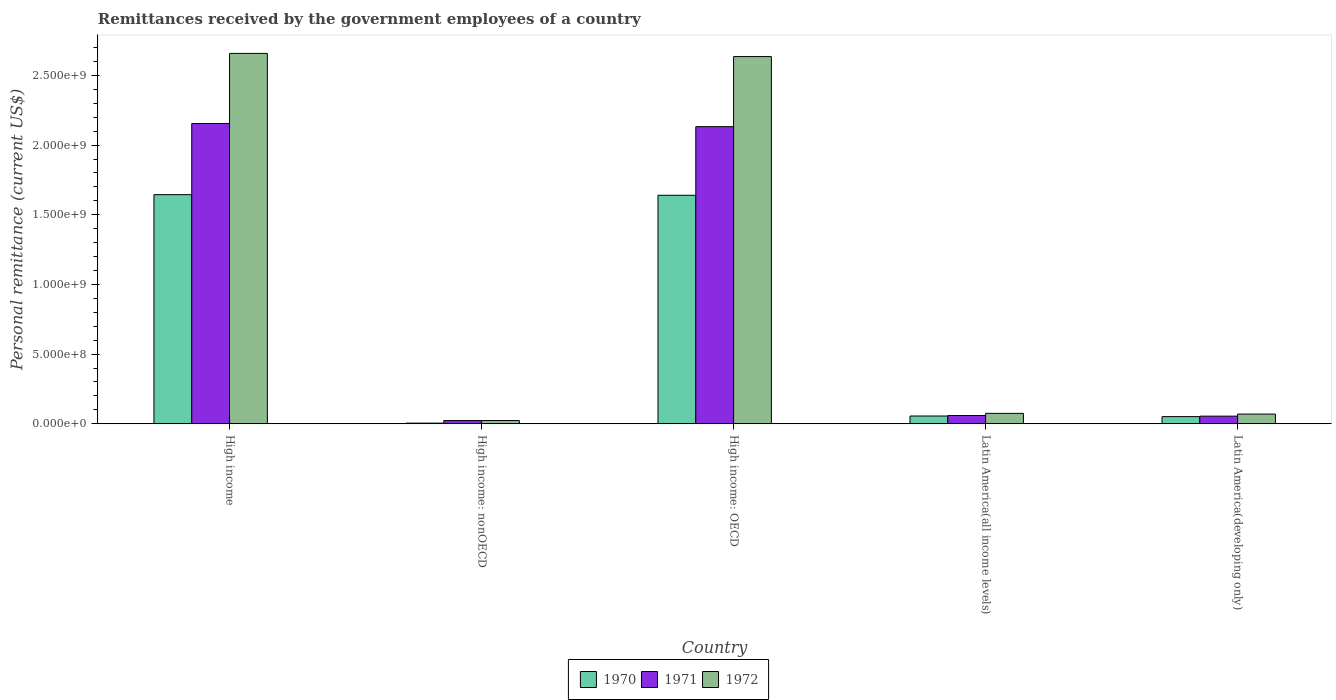Are the number of bars per tick equal to the number of legend labels?
Keep it short and to the point. Yes. Are the number of bars on each tick of the X-axis equal?
Your answer should be compact. Yes. How many bars are there on the 5th tick from the left?
Your answer should be very brief. 3. How many bars are there on the 4th tick from the right?
Ensure brevity in your answer.  3. What is the remittances received by the government employees in 1972 in Latin America(all income levels)?
Give a very brief answer. 7.45e+07. Across all countries, what is the maximum remittances received by the government employees in 1970?
Keep it short and to the point. 1.64e+09. Across all countries, what is the minimum remittances received by the government employees in 1972?
Your response must be concise. 2.29e+07. In which country was the remittances received by the government employees in 1972 minimum?
Offer a terse response. High income: nonOECD. What is the total remittances received by the government employees in 1970 in the graph?
Keep it short and to the point. 3.40e+09. What is the difference between the remittances received by the government employees in 1970 in High income: nonOECD and that in Latin America(developing only)?
Your response must be concise. -4.67e+07. What is the difference between the remittances received by the government employees in 1972 in Latin America(all income levels) and the remittances received by the government employees in 1971 in Latin America(developing only)?
Your answer should be compact. 2.00e+07. What is the average remittances received by the government employees in 1970 per country?
Offer a very short reply. 6.79e+08. What is the difference between the remittances received by the government employees of/in 1972 and remittances received by the government employees of/in 1971 in Latin America(developing only)?
Offer a very short reply. 1.49e+07. What is the ratio of the remittances received by the government employees in 1972 in High income: nonOECD to that in Latin America(all income levels)?
Make the answer very short. 0.31. Is the remittances received by the government employees in 1972 in High income less than that in High income: nonOECD?
Your answer should be compact. No. What is the difference between the highest and the second highest remittances received by the government employees in 1970?
Keep it short and to the point. -1.59e+09. What is the difference between the highest and the lowest remittances received by the government employees in 1970?
Offer a terse response. 1.64e+09. What does the 3rd bar from the left in High income: OECD represents?
Provide a succinct answer. 1972. Is it the case that in every country, the sum of the remittances received by the government employees in 1971 and remittances received by the government employees in 1972 is greater than the remittances received by the government employees in 1970?
Your response must be concise. Yes. How many bars are there?
Keep it short and to the point. 15. How many countries are there in the graph?
Keep it short and to the point. 5. What is the difference between two consecutive major ticks on the Y-axis?
Provide a succinct answer. 5.00e+08. Are the values on the major ticks of Y-axis written in scientific E-notation?
Keep it short and to the point. Yes. Does the graph contain grids?
Your response must be concise. No. How many legend labels are there?
Offer a terse response. 3. How are the legend labels stacked?
Your answer should be very brief. Horizontal. What is the title of the graph?
Provide a succinct answer. Remittances received by the government employees of a country. What is the label or title of the Y-axis?
Offer a very short reply. Personal remittance (current US$). What is the Personal remittance (current US$) in 1970 in High income?
Offer a very short reply. 1.64e+09. What is the Personal remittance (current US$) in 1971 in High income?
Provide a succinct answer. 2.16e+09. What is the Personal remittance (current US$) of 1972 in High income?
Provide a short and direct response. 2.66e+09. What is the Personal remittance (current US$) of 1970 in High income: nonOECD?
Provide a succinct answer. 4.40e+06. What is the Personal remittance (current US$) of 1971 in High income: nonOECD?
Give a very brief answer. 2.28e+07. What is the Personal remittance (current US$) in 1972 in High income: nonOECD?
Your answer should be very brief. 2.29e+07. What is the Personal remittance (current US$) in 1970 in High income: OECD?
Offer a very short reply. 1.64e+09. What is the Personal remittance (current US$) in 1971 in High income: OECD?
Offer a terse response. 2.13e+09. What is the Personal remittance (current US$) of 1972 in High income: OECD?
Ensure brevity in your answer.  2.64e+09. What is the Personal remittance (current US$) in 1970 in Latin America(all income levels)?
Provide a succinct answer. 5.55e+07. What is the Personal remittance (current US$) in 1971 in Latin America(all income levels)?
Provide a succinct answer. 5.91e+07. What is the Personal remittance (current US$) of 1972 in Latin America(all income levels)?
Your response must be concise. 7.45e+07. What is the Personal remittance (current US$) of 1970 in Latin America(developing only)?
Ensure brevity in your answer.  5.11e+07. What is the Personal remittance (current US$) in 1971 in Latin America(developing only)?
Offer a very short reply. 5.45e+07. What is the Personal remittance (current US$) of 1972 in Latin America(developing only)?
Your response must be concise. 6.94e+07. Across all countries, what is the maximum Personal remittance (current US$) of 1970?
Give a very brief answer. 1.64e+09. Across all countries, what is the maximum Personal remittance (current US$) of 1971?
Your answer should be very brief. 2.16e+09. Across all countries, what is the maximum Personal remittance (current US$) of 1972?
Give a very brief answer. 2.66e+09. Across all countries, what is the minimum Personal remittance (current US$) in 1970?
Offer a very short reply. 4.40e+06. Across all countries, what is the minimum Personal remittance (current US$) of 1971?
Your answer should be very brief. 2.28e+07. Across all countries, what is the minimum Personal remittance (current US$) in 1972?
Offer a very short reply. 2.29e+07. What is the total Personal remittance (current US$) in 1970 in the graph?
Your answer should be compact. 3.40e+09. What is the total Personal remittance (current US$) in 1971 in the graph?
Your answer should be very brief. 4.42e+09. What is the total Personal remittance (current US$) of 1972 in the graph?
Ensure brevity in your answer.  5.46e+09. What is the difference between the Personal remittance (current US$) in 1970 in High income and that in High income: nonOECD?
Provide a succinct answer. 1.64e+09. What is the difference between the Personal remittance (current US$) in 1971 in High income and that in High income: nonOECD?
Provide a short and direct response. 2.13e+09. What is the difference between the Personal remittance (current US$) in 1972 in High income and that in High income: nonOECD?
Your answer should be compact. 2.64e+09. What is the difference between the Personal remittance (current US$) in 1970 in High income and that in High income: OECD?
Ensure brevity in your answer.  4.40e+06. What is the difference between the Personal remittance (current US$) of 1971 in High income and that in High income: OECD?
Make the answer very short. 2.28e+07. What is the difference between the Personal remittance (current US$) of 1972 in High income and that in High income: OECD?
Give a very brief answer. 2.29e+07. What is the difference between the Personal remittance (current US$) in 1970 in High income and that in Latin America(all income levels)?
Offer a very short reply. 1.59e+09. What is the difference between the Personal remittance (current US$) in 1971 in High income and that in Latin America(all income levels)?
Your answer should be very brief. 2.10e+09. What is the difference between the Personal remittance (current US$) of 1972 in High income and that in Latin America(all income levels)?
Your answer should be very brief. 2.58e+09. What is the difference between the Personal remittance (current US$) of 1970 in High income and that in Latin America(developing only)?
Provide a short and direct response. 1.59e+09. What is the difference between the Personal remittance (current US$) of 1971 in High income and that in Latin America(developing only)?
Your answer should be very brief. 2.10e+09. What is the difference between the Personal remittance (current US$) in 1972 in High income and that in Latin America(developing only)?
Your answer should be compact. 2.59e+09. What is the difference between the Personal remittance (current US$) in 1970 in High income: nonOECD and that in High income: OECD?
Offer a terse response. -1.64e+09. What is the difference between the Personal remittance (current US$) in 1971 in High income: nonOECD and that in High income: OECD?
Provide a succinct answer. -2.11e+09. What is the difference between the Personal remittance (current US$) in 1972 in High income: nonOECD and that in High income: OECD?
Provide a short and direct response. -2.61e+09. What is the difference between the Personal remittance (current US$) of 1970 in High income: nonOECD and that in Latin America(all income levels)?
Offer a terse response. -5.11e+07. What is the difference between the Personal remittance (current US$) in 1971 in High income: nonOECD and that in Latin America(all income levels)?
Make the answer very short. -3.63e+07. What is the difference between the Personal remittance (current US$) of 1972 in High income: nonOECD and that in Latin America(all income levels)?
Offer a terse response. -5.16e+07. What is the difference between the Personal remittance (current US$) of 1970 in High income: nonOECD and that in Latin America(developing only)?
Provide a succinct answer. -4.67e+07. What is the difference between the Personal remittance (current US$) in 1971 in High income: nonOECD and that in Latin America(developing only)?
Make the answer very short. -3.17e+07. What is the difference between the Personal remittance (current US$) of 1972 in High income: nonOECD and that in Latin America(developing only)?
Your response must be concise. -4.65e+07. What is the difference between the Personal remittance (current US$) in 1970 in High income: OECD and that in Latin America(all income levels)?
Make the answer very short. 1.58e+09. What is the difference between the Personal remittance (current US$) in 1971 in High income: OECD and that in Latin America(all income levels)?
Make the answer very short. 2.07e+09. What is the difference between the Personal remittance (current US$) of 1972 in High income: OECD and that in Latin America(all income levels)?
Provide a succinct answer. 2.56e+09. What is the difference between the Personal remittance (current US$) in 1970 in High income: OECD and that in Latin America(developing only)?
Offer a terse response. 1.59e+09. What is the difference between the Personal remittance (current US$) in 1971 in High income: OECD and that in Latin America(developing only)?
Offer a very short reply. 2.08e+09. What is the difference between the Personal remittance (current US$) in 1972 in High income: OECD and that in Latin America(developing only)?
Give a very brief answer. 2.57e+09. What is the difference between the Personal remittance (current US$) of 1970 in Latin America(all income levels) and that in Latin America(developing only)?
Provide a succinct answer. 4.40e+06. What is the difference between the Personal remittance (current US$) of 1971 in Latin America(all income levels) and that in Latin America(developing only)?
Your answer should be compact. 4.61e+06. What is the difference between the Personal remittance (current US$) in 1972 in Latin America(all income levels) and that in Latin America(developing only)?
Your answer should be very brief. 5.10e+06. What is the difference between the Personal remittance (current US$) in 1970 in High income and the Personal remittance (current US$) in 1971 in High income: nonOECD?
Provide a short and direct response. 1.62e+09. What is the difference between the Personal remittance (current US$) of 1970 in High income and the Personal remittance (current US$) of 1972 in High income: nonOECD?
Make the answer very short. 1.62e+09. What is the difference between the Personal remittance (current US$) of 1971 in High income and the Personal remittance (current US$) of 1972 in High income: nonOECD?
Your answer should be very brief. 2.13e+09. What is the difference between the Personal remittance (current US$) in 1970 in High income and the Personal remittance (current US$) in 1971 in High income: OECD?
Provide a short and direct response. -4.88e+08. What is the difference between the Personal remittance (current US$) of 1970 in High income and the Personal remittance (current US$) of 1972 in High income: OECD?
Give a very brief answer. -9.91e+08. What is the difference between the Personal remittance (current US$) of 1971 in High income and the Personal remittance (current US$) of 1972 in High income: OECD?
Your response must be concise. -4.80e+08. What is the difference between the Personal remittance (current US$) of 1970 in High income and the Personal remittance (current US$) of 1971 in Latin America(all income levels)?
Give a very brief answer. 1.59e+09. What is the difference between the Personal remittance (current US$) of 1970 in High income and the Personal remittance (current US$) of 1972 in Latin America(all income levels)?
Keep it short and to the point. 1.57e+09. What is the difference between the Personal remittance (current US$) in 1971 in High income and the Personal remittance (current US$) in 1972 in Latin America(all income levels)?
Your answer should be compact. 2.08e+09. What is the difference between the Personal remittance (current US$) in 1970 in High income and the Personal remittance (current US$) in 1971 in Latin America(developing only)?
Ensure brevity in your answer.  1.59e+09. What is the difference between the Personal remittance (current US$) of 1970 in High income and the Personal remittance (current US$) of 1972 in Latin America(developing only)?
Ensure brevity in your answer.  1.58e+09. What is the difference between the Personal remittance (current US$) in 1971 in High income and the Personal remittance (current US$) in 1972 in Latin America(developing only)?
Your response must be concise. 2.09e+09. What is the difference between the Personal remittance (current US$) in 1970 in High income: nonOECD and the Personal remittance (current US$) in 1971 in High income: OECD?
Ensure brevity in your answer.  -2.13e+09. What is the difference between the Personal remittance (current US$) in 1970 in High income: nonOECD and the Personal remittance (current US$) in 1972 in High income: OECD?
Offer a terse response. -2.63e+09. What is the difference between the Personal remittance (current US$) in 1971 in High income: nonOECD and the Personal remittance (current US$) in 1972 in High income: OECD?
Your answer should be compact. -2.61e+09. What is the difference between the Personal remittance (current US$) of 1970 in High income: nonOECD and the Personal remittance (current US$) of 1971 in Latin America(all income levels)?
Keep it short and to the point. -5.47e+07. What is the difference between the Personal remittance (current US$) in 1970 in High income: nonOECD and the Personal remittance (current US$) in 1972 in Latin America(all income levels)?
Offer a very short reply. -7.01e+07. What is the difference between the Personal remittance (current US$) of 1971 in High income: nonOECD and the Personal remittance (current US$) of 1972 in Latin America(all income levels)?
Make the answer very short. -5.17e+07. What is the difference between the Personal remittance (current US$) in 1970 in High income: nonOECD and the Personal remittance (current US$) in 1971 in Latin America(developing only)?
Offer a terse response. -5.01e+07. What is the difference between the Personal remittance (current US$) of 1970 in High income: nonOECD and the Personal remittance (current US$) of 1972 in Latin America(developing only)?
Your response must be concise. -6.50e+07. What is the difference between the Personal remittance (current US$) of 1971 in High income: nonOECD and the Personal remittance (current US$) of 1972 in Latin America(developing only)?
Provide a succinct answer. -4.66e+07. What is the difference between the Personal remittance (current US$) in 1970 in High income: OECD and the Personal remittance (current US$) in 1971 in Latin America(all income levels)?
Make the answer very short. 1.58e+09. What is the difference between the Personal remittance (current US$) in 1970 in High income: OECD and the Personal remittance (current US$) in 1972 in Latin America(all income levels)?
Offer a very short reply. 1.57e+09. What is the difference between the Personal remittance (current US$) of 1971 in High income: OECD and the Personal remittance (current US$) of 1972 in Latin America(all income levels)?
Offer a very short reply. 2.06e+09. What is the difference between the Personal remittance (current US$) of 1970 in High income: OECD and the Personal remittance (current US$) of 1971 in Latin America(developing only)?
Make the answer very short. 1.59e+09. What is the difference between the Personal remittance (current US$) of 1970 in High income: OECD and the Personal remittance (current US$) of 1972 in Latin America(developing only)?
Your response must be concise. 1.57e+09. What is the difference between the Personal remittance (current US$) in 1971 in High income: OECD and the Personal remittance (current US$) in 1972 in Latin America(developing only)?
Offer a very short reply. 2.06e+09. What is the difference between the Personal remittance (current US$) of 1970 in Latin America(all income levels) and the Personal remittance (current US$) of 1971 in Latin America(developing only)?
Provide a succinct answer. 1.03e+06. What is the difference between the Personal remittance (current US$) of 1970 in Latin America(all income levels) and the Personal remittance (current US$) of 1972 in Latin America(developing only)?
Provide a short and direct response. -1.39e+07. What is the difference between the Personal remittance (current US$) in 1971 in Latin America(all income levels) and the Personal remittance (current US$) in 1972 in Latin America(developing only)?
Provide a short and direct response. -1.03e+07. What is the average Personal remittance (current US$) in 1970 per country?
Your answer should be very brief. 6.79e+08. What is the average Personal remittance (current US$) of 1971 per country?
Ensure brevity in your answer.  8.85e+08. What is the average Personal remittance (current US$) in 1972 per country?
Provide a succinct answer. 1.09e+09. What is the difference between the Personal remittance (current US$) of 1970 and Personal remittance (current US$) of 1971 in High income?
Ensure brevity in your answer.  -5.11e+08. What is the difference between the Personal remittance (current US$) in 1970 and Personal remittance (current US$) in 1972 in High income?
Your answer should be very brief. -1.01e+09. What is the difference between the Personal remittance (current US$) in 1971 and Personal remittance (current US$) in 1972 in High income?
Provide a succinct answer. -5.03e+08. What is the difference between the Personal remittance (current US$) of 1970 and Personal remittance (current US$) of 1971 in High income: nonOECD?
Provide a short and direct response. -1.84e+07. What is the difference between the Personal remittance (current US$) in 1970 and Personal remittance (current US$) in 1972 in High income: nonOECD?
Keep it short and to the point. -1.85e+07. What is the difference between the Personal remittance (current US$) of 1971 and Personal remittance (current US$) of 1972 in High income: nonOECD?
Give a very brief answer. -1.37e+05. What is the difference between the Personal remittance (current US$) in 1970 and Personal remittance (current US$) in 1971 in High income: OECD?
Make the answer very short. -4.92e+08. What is the difference between the Personal remittance (current US$) in 1970 and Personal remittance (current US$) in 1972 in High income: OECD?
Offer a very short reply. -9.96e+08. What is the difference between the Personal remittance (current US$) in 1971 and Personal remittance (current US$) in 1972 in High income: OECD?
Provide a short and direct response. -5.03e+08. What is the difference between the Personal remittance (current US$) of 1970 and Personal remittance (current US$) of 1971 in Latin America(all income levels)?
Keep it short and to the point. -3.57e+06. What is the difference between the Personal remittance (current US$) in 1970 and Personal remittance (current US$) in 1972 in Latin America(all income levels)?
Your answer should be very brief. -1.90e+07. What is the difference between the Personal remittance (current US$) of 1971 and Personal remittance (current US$) of 1972 in Latin America(all income levels)?
Your answer should be compact. -1.54e+07. What is the difference between the Personal remittance (current US$) in 1970 and Personal remittance (current US$) in 1971 in Latin America(developing only)?
Provide a short and direct response. -3.37e+06. What is the difference between the Personal remittance (current US$) in 1970 and Personal remittance (current US$) in 1972 in Latin America(developing only)?
Your answer should be very brief. -1.83e+07. What is the difference between the Personal remittance (current US$) of 1971 and Personal remittance (current US$) of 1972 in Latin America(developing only)?
Make the answer very short. -1.49e+07. What is the ratio of the Personal remittance (current US$) in 1970 in High income to that in High income: nonOECD?
Keep it short and to the point. 373.75. What is the ratio of the Personal remittance (current US$) in 1971 in High income to that in High income: nonOECD?
Give a very brief answer. 94.6. What is the ratio of the Personal remittance (current US$) in 1972 in High income to that in High income: nonOECD?
Offer a terse response. 115.99. What is the ratio of the Personal remittance (current US$) of 1970 in High income to that in High income: OECD?
Ensure brevity in your answer.  1. What is the ratio of the Personal remittance (current US$) in 1971 in High income to that in High income: OECD?
Offer a very short reply. 1.01. What is the ratio of the Personal remittance (current US$) of 1972 in High income to that in High income: OECD?
Provide a succinct answer. 1.01. What is the ratio of the Personal remittance (current US$) in 1970 in High income to that in Latin America(all income levels)?
Provide a succinct answer. 29.63. What is the ratio of the Personal remittance (current US$) in 1971 in High income to that in Latin America(all income levels)?
Offer a very short reply. 36.49. What is the ratio of the Personal remittance (current US$) of 1972 in High income to that in Latin America(all income levels)?
Keep it short and to the point. 35.7. What is the ratio of the Personal remittance (current US$) of 1970 in High income to that in Latin America(developing only)?
Your response must be concise. 32.18. What is the ratio of the Personal remittance (current US$) of 1971 in High income to that in Latin America(developing only)?
Provide a short and direct response. 39.57. What is the ratio of the Personal remittance (current US$) in 1972 in High income to that in Latin America(developing only)?
Keep it short and to the point. 38.32. What is the ratio of the Personal remittance (current US$) in 1970 in High income: nonOECD to that in High income: OECD?
Provide a short and direct response. 0. What is the ratio of the Personal remittance (current US$) of 1971 in High income: nonOECD to that in High income: OECD?
Make the answer very short. 0.01. What is the ratio of the Personal remittance (current US$) in 1972 in High income: nonOECD to that in High income: OECD?
Offer a terse response. 0.01. What is the ratio of the Personal remittance (current US$) in 1970 in High income: nonOECD to that in Latin America(all income levels)?
Make the answer very short. 0.08. What is the ratio of the Personal remittance (current US$) of 1971 in High income: nonOECD to that in Latin America(all income levels)?
Keep it short and to the point. 0.39. What is the ratio of the Personal remittance (current US$) of 1972 in High income: nonOECD to that in Latin America(all income levels)?
Give a very brief answer. 0.31. What is the ratio of the Personal remittance (current US$) of 1970 in High income: nonOECD to that in Latin America(developing only)?
Give a very brief answer. 0.09. What is the ratio of the Personal remittance (current US$) in 1971 in High income: nonOECD to that in Latin America(developing only)?
Make the answer very short. 0.42. What is the ratio of the Personal remittance (current US$) of 1972 in High income: nonOECD to that in Latin America(developing only)?
Give a very brief answer. 0.33. What is the ratio of the Personal remittance (current US$) of 1970 in High income: OECD to that in Latin America(all income levels)?
Your response must be concise. 29.55. What is the ratio of the Personal remittance (current US$) in 1971 in High income: OECD to that in Latin America(all income levels)?
Make the answer very short. 36.1. What is the ratio of the Personal remittance (current US$) of 1972 in High income: OECD to that in Latin America(all income levels)?
Give a very brief answer. 35.39. What is the ratio of the Personal remittance (current US$) in 1970 in High income: OECD to that in Latin America(developing only)?
Provide a succinct answer. 32.1. What is the ratio of the Personal remittance (current US$) of 1971 in High income: OECD to that in Latin America(developing only)?
Your answer should be very brief. 39.15. What is the ratio of the Personal remittance (current US$) of 1972 in High income: OECD to that in Latin America(developing only)?
Make the answer very short. 37.99. What is the ratio of the Personal remittance (current US$) of 1970 in Latin America(all income levels) to that in Latin America(developing only)?
Make the answer very short. 1.09. What is the ratio of the Personal remittance (current US$) of 1971 in Latin America(all income levels) to that in Latin America(developing only)?
Your answer should be compact. 1.08. What is the ratio of the Personal remittance (current US$) of 1972 in Latin America(all income levels) to that in Latin America(developing only)?
Your answer should be compact. 1.07. What is the difference between the highest and the second highest Personal remittance (current US$) of 1970?
Offer a very short reply. 4.40e+06. What is the difference between the highest and the second highest Personal remittance (current US$) of 1971?
Your response must be concise. 2.28e+07. What is the difference between the highest and the second highest Personal remittance (current US$) of 1972?
Offer a terse response. 2.29e+07. What is the difference between the highest and the lowest Personal remittance (current US$) in 1970?
Give a very brief answer. 1.64e+09. What is the difference between the highest and the lowest Personal remittance (current US$) in 1971?
Provide a short and direct response. 2.13e+09. What is the difference between the highest and the lowest Personal remittance (current US$) in 1972?
Your answer should be very brief. 2.64e+09. 